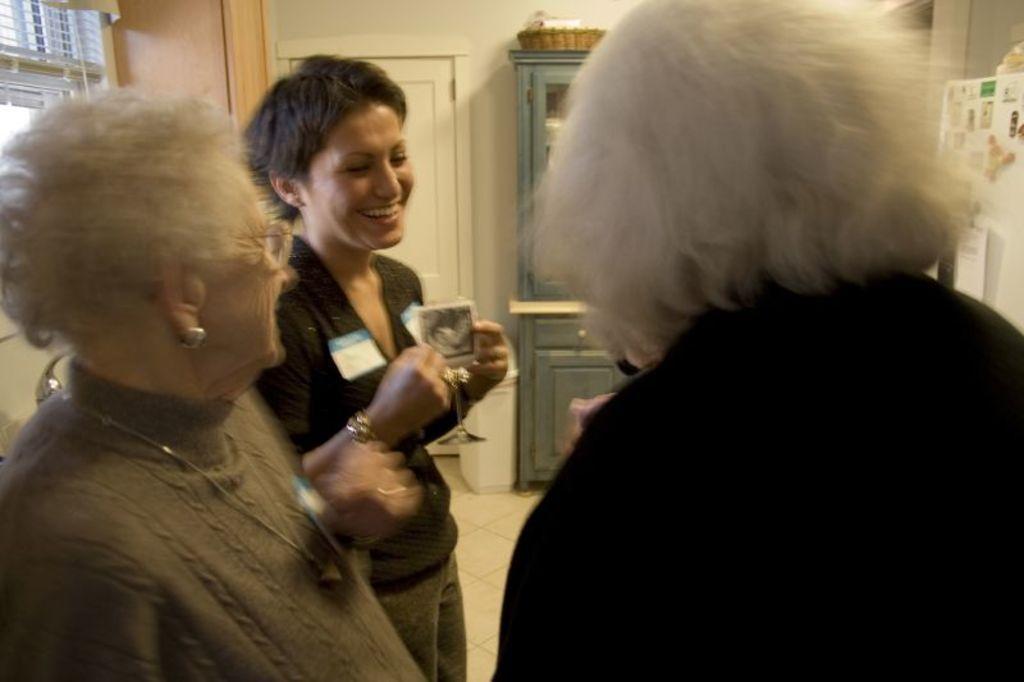Can you describe this image briefly? In this image we can see three women standing on the floor. One of them is holding a glass. On the backside we can see a window, curtain, door, wall and basket on the cupboard. 